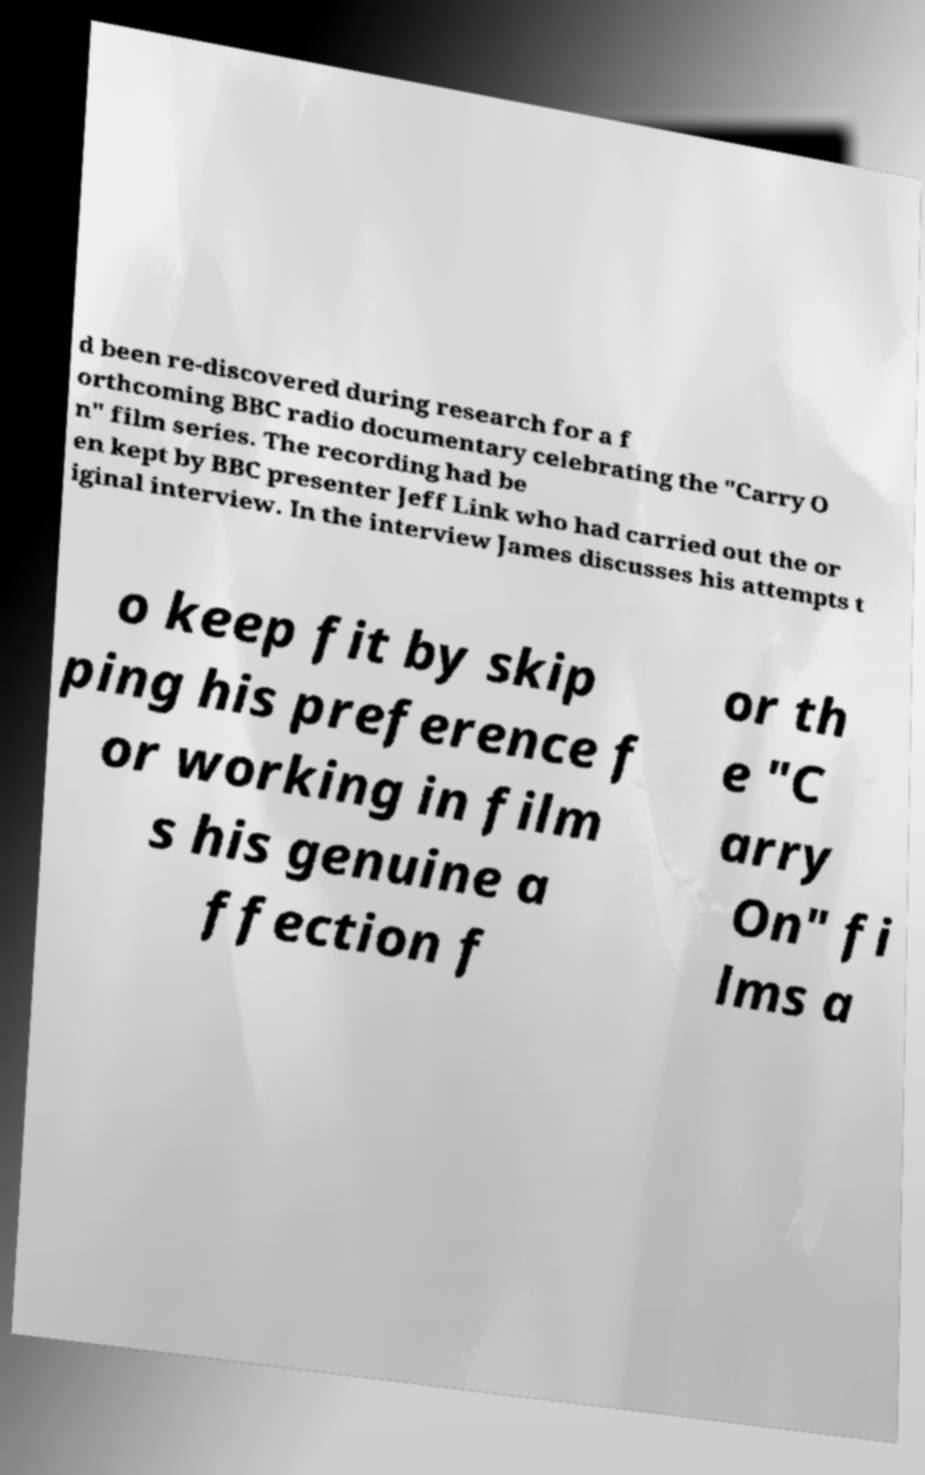I need the written content from this picture converted into text. Can you do that? d been re-discovered during research for a f orthcoming BBC radio documentary celebrating the "Carry O n" film series. The recording had be en kept by BBC presenter Jeff Link who had carried out the or iginal interview. In the interview James discusses his attempts t o keep fit by skip ping his preference f or working in film s his genuine a ffection f or th e "C arry On" fi lms a 